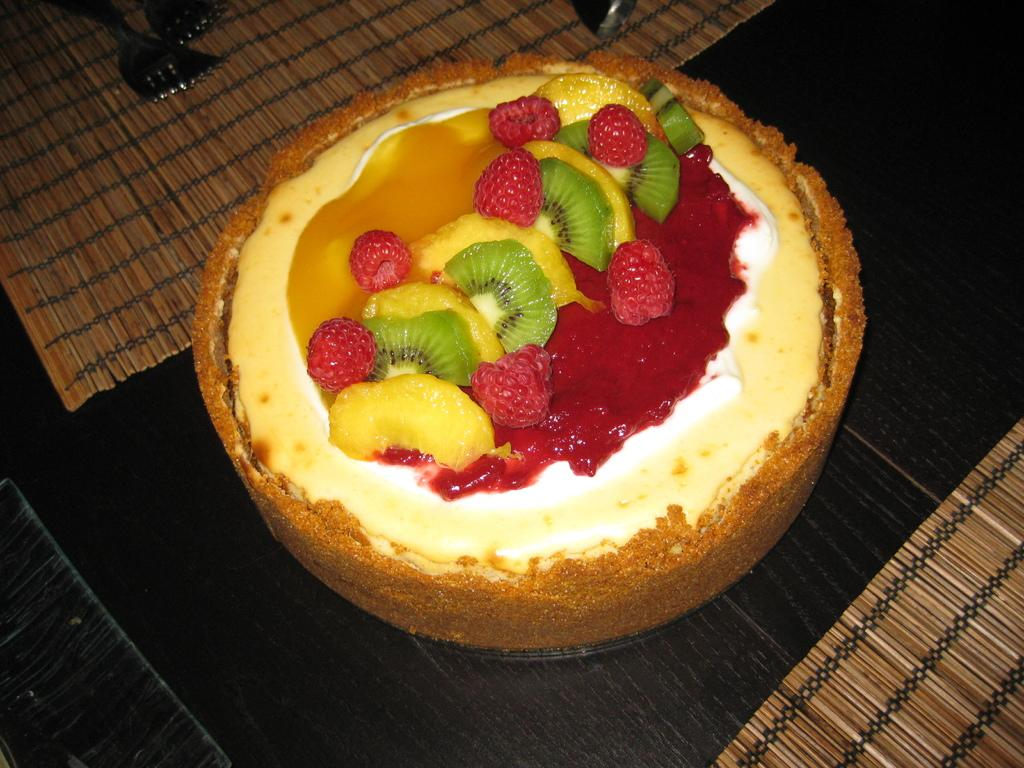What is the main food item featured in the image? There is a cake in the image. What type of fruit is present in the image? There are strawberries in the image. What other types of fruits can be seen in the image? There are fruits in the image, but the specific types are not mentioned. What utensils are visible in the image? There are forks in the image. What is on the platform in the image? There are mats on the platform in the image. What type of quilt is draped over the cake in the image? There is no quilt present in the image; it features a cake, strawberries, fruits, forks, and mats on a platform. 